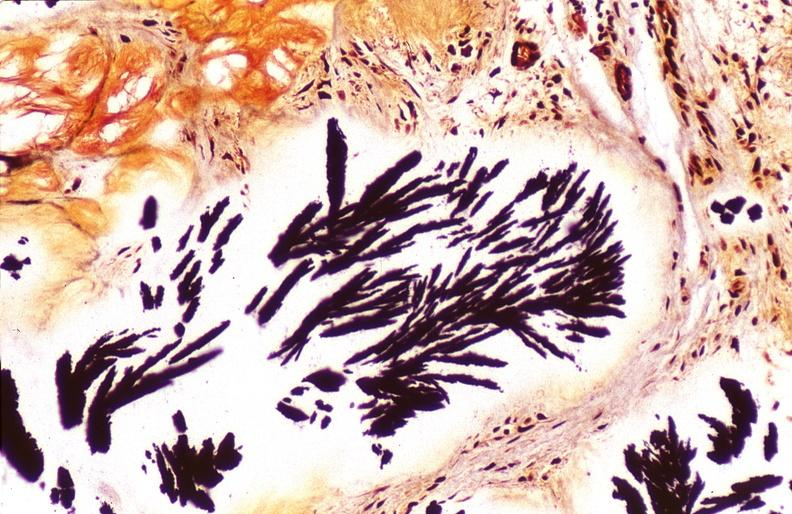does this image show gout, alcohol fixed tissues, monosodium urate crystals?
Answer the question using a single word or phrase. Yes 